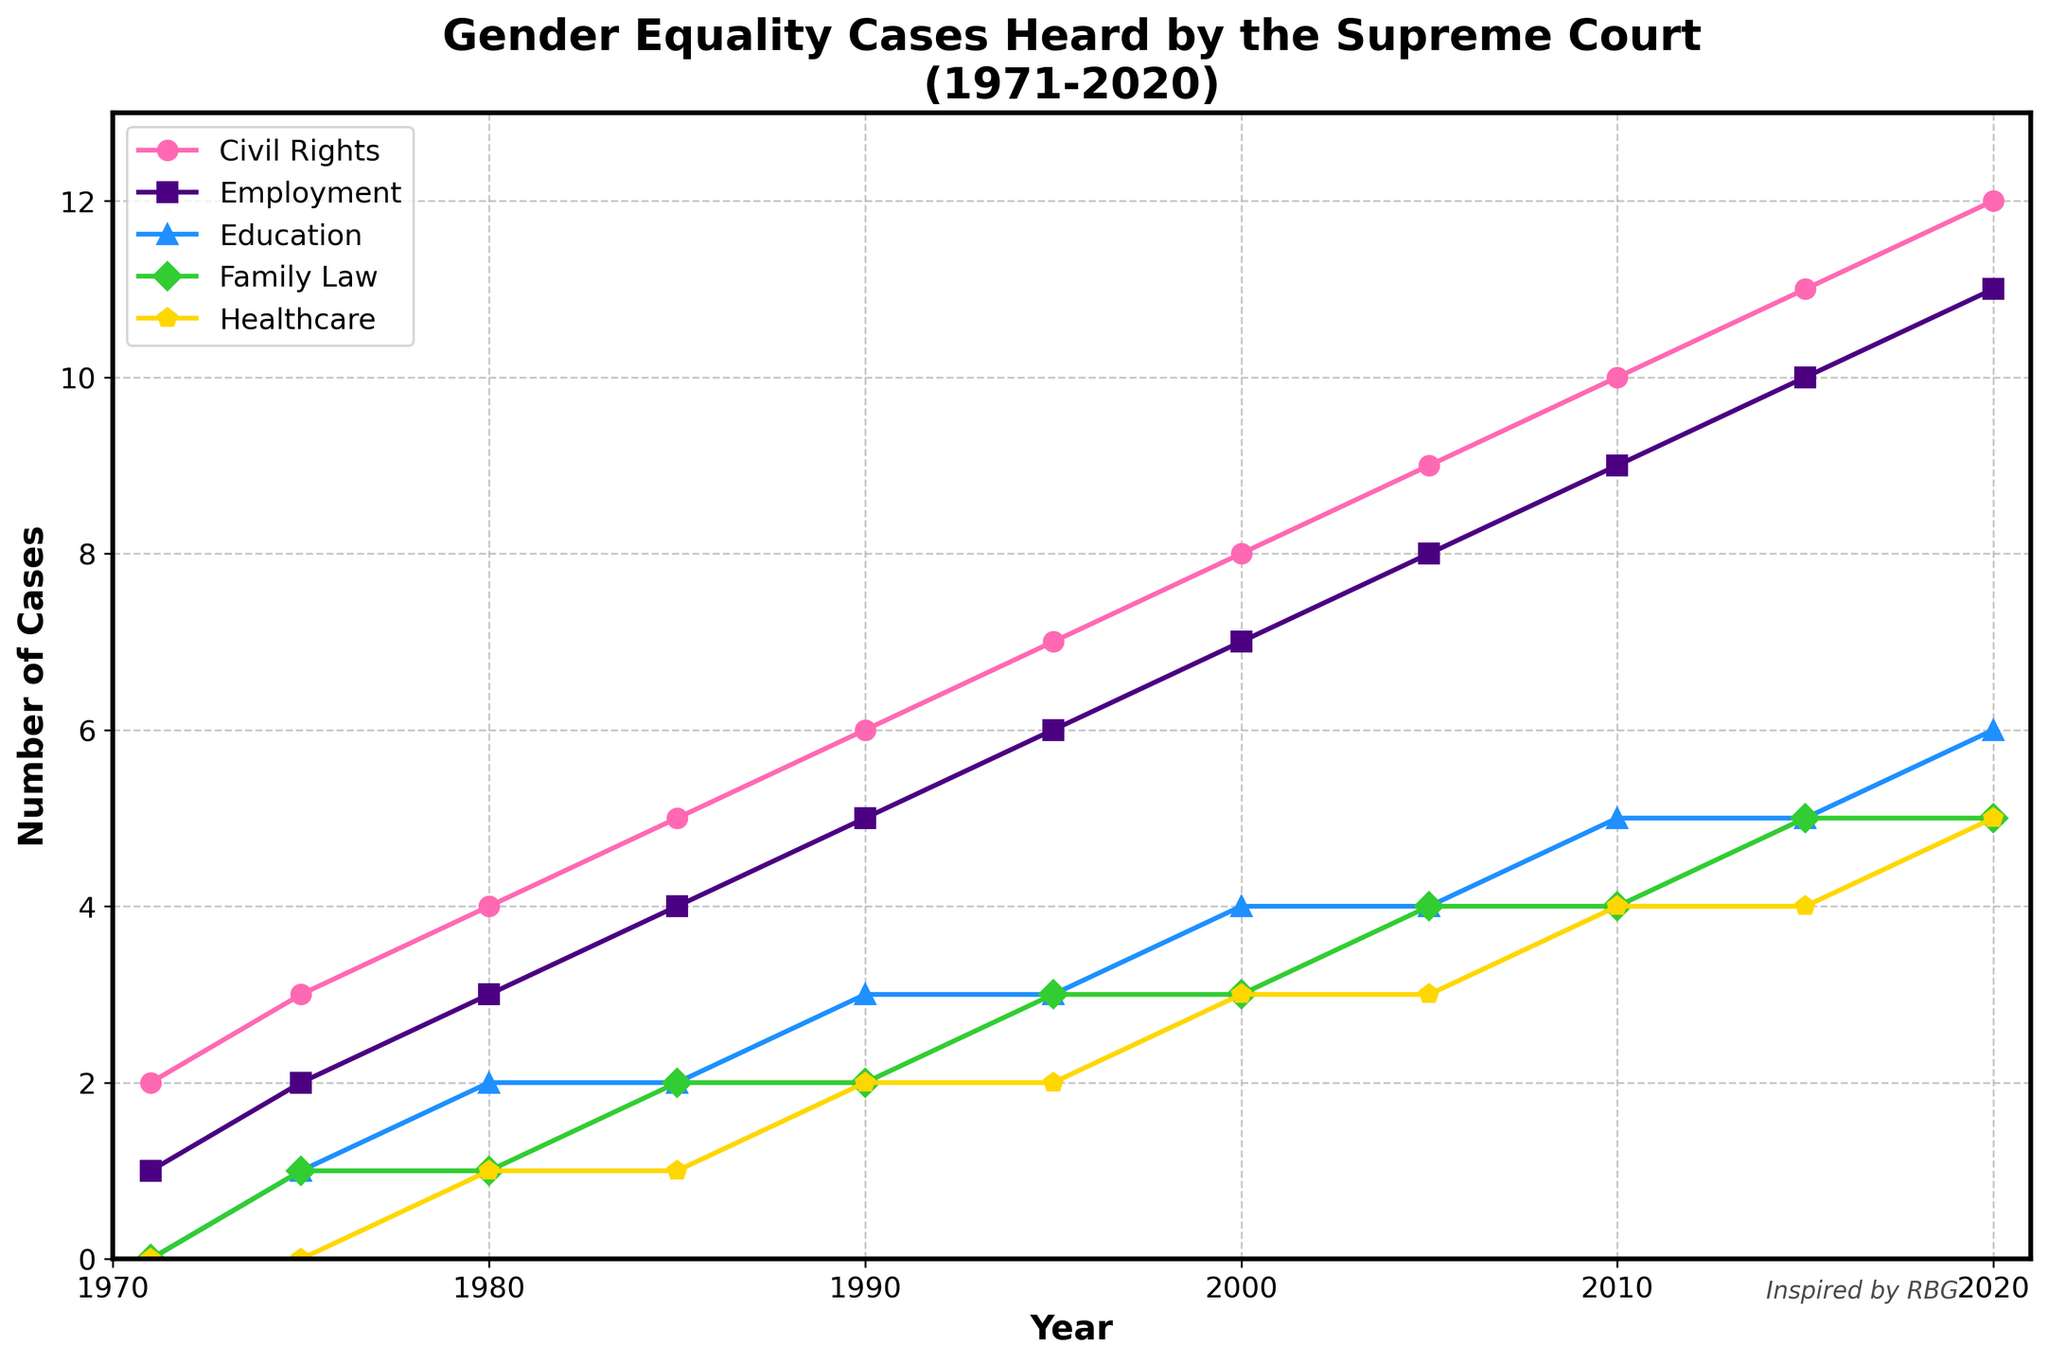How many gender equality cases related to Civil Rights were heard by the Supreme Court in 2020? We look at the line corresponding to Civil Rights for the year 2020. The value is 12.
Answer: 12 Which legal area had the highest number of cases heard in 1990? We compare the values for all legal areas in 1990. Civil Rights has the highest value with 6 cases.
Answer: Civil Rights Between 1975 and 1985, did the number of gender equality cases related to Employment increase or decrease? We look at the Employment values for 1975 and 1985. The number increases from 2 to 4.
Answer: Increase By how much did the number of Family Law cases increase from 1980 to 2000? In 1980, Family Law had 1 case, and by 2000, it had 3 cases. The increase is 3 - 1 = 2.
Answer: 2 In which year did Healthcare cases first reach 3? We trace along the Healthcare line until we first see the value 3, which is in 2000.
Answer: 2000 What is the average number of Education cases heard between 1975 and 2000? We sum the number of Education cases from 1975 (1), 1980 (2), 1985 (2), 1990 (3), 1995 (3), and 2000 (4) and divide by the number of years: (1+2+2+3+3+4)/6 = 2.5.
Answer: 2.5 What trend do we see in the number of Civil Rights cases from 1971 to 2020? We observe the trend from the start to the end of the Civil Rights line plot. The number of cases shows a steady increase from 2 to 12.
Answer: Steady increase By how much did the total number of cases across all legal areas increase from 1971 to 2020? Summing up the cases for all legal areas in 1971 gives 2+1+0+0+0 = 3, and for 2020, it is 12+11+6+5+5 = 39. The increase is 39 - 3 = 36.
Answer: 36 Which legal area had the slowest growth in the number of gender equality cases from 1971 to 2010? We compare the growth for each legal area by subtracting the 1971 value from the 2010 value. Civil Rights (10-2=8), Employment (9-1=8), Education (5-0=5), Family Law (4-0=4), Healthcare (4-0=4). Family Law and Healthcare have the slowest growth, both with an increase of 4 cases.
Answer: Family Law, Healthcare 